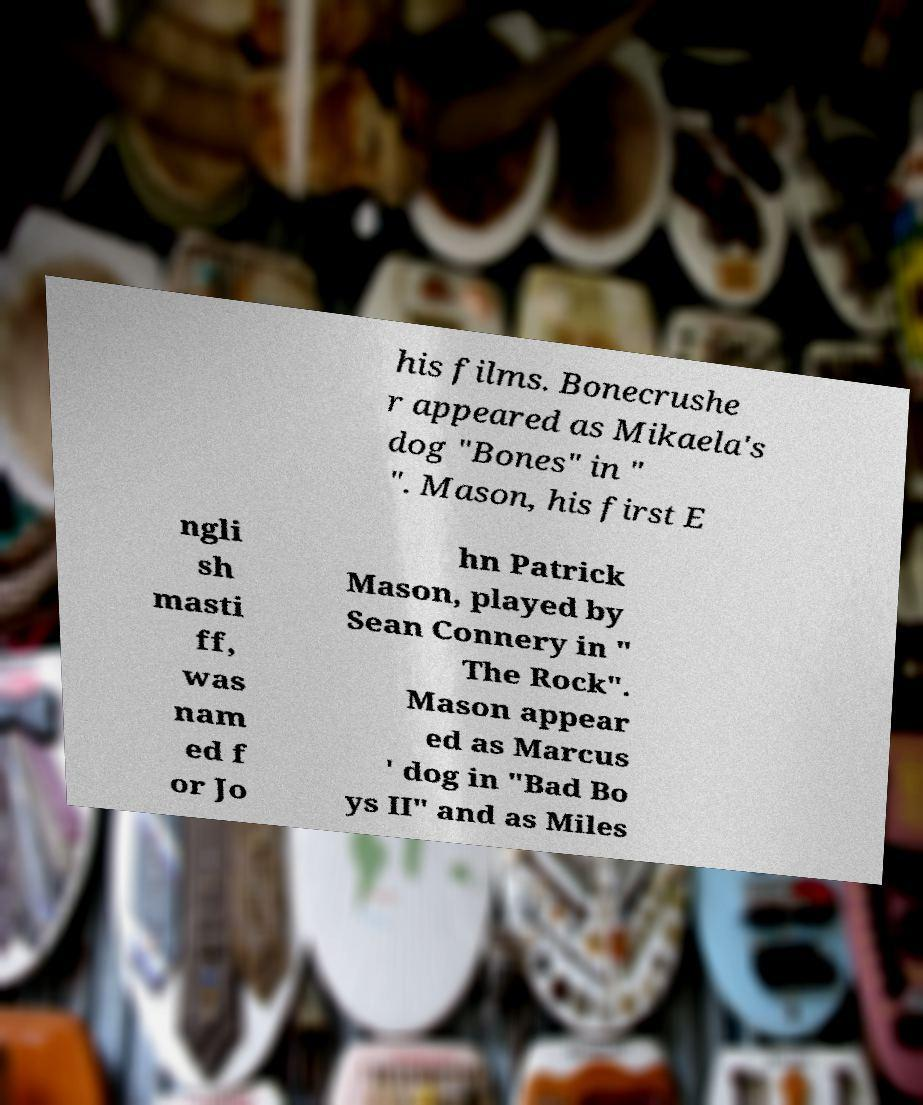There's text embedded in this image that I need extracted. Can you transcribe it verbatim? his films. Bonecrushe r appeared as Mikaela's dog "Bones" in " ". Mason, his first E ngli sh masti ff, was nam ed f or Jo hn Patrick Mason, played by Sean Connery in " The Rock". Mason appear ed as Marcus ' dog in "Bad Bo ys II" and as Miles 